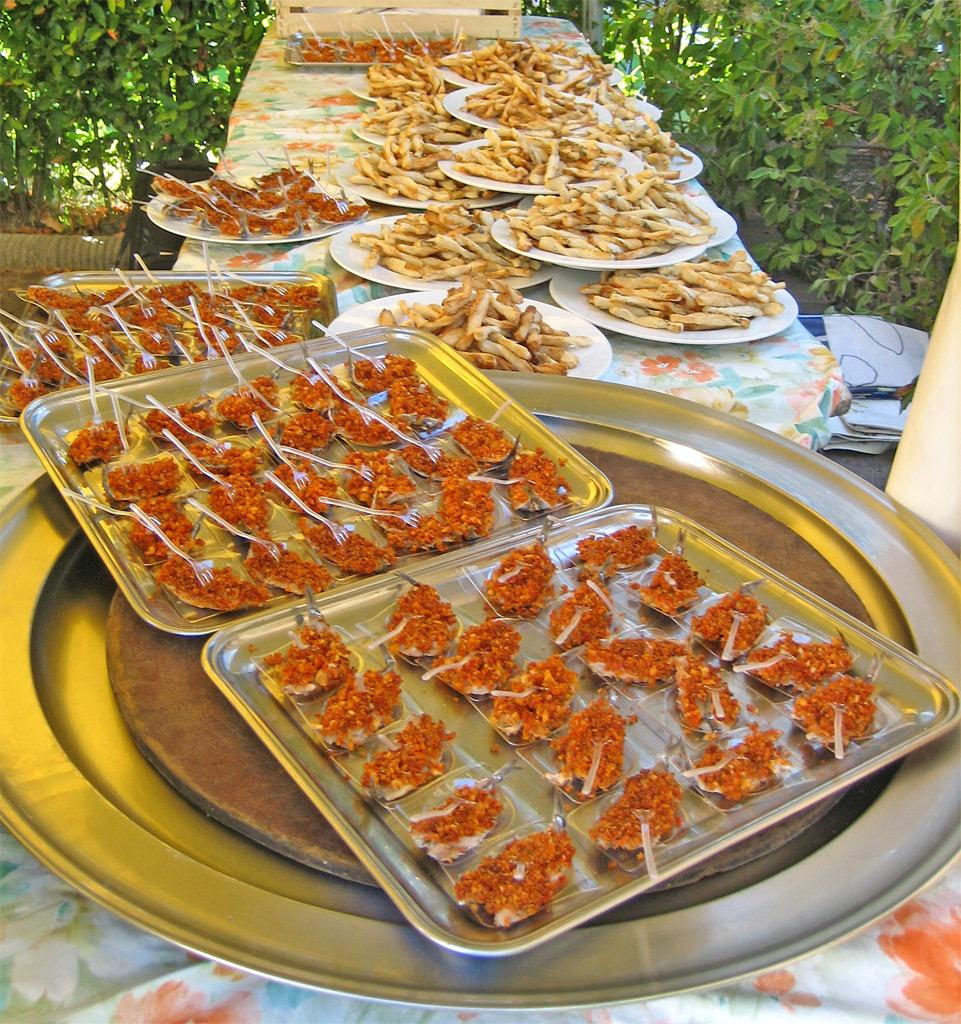What is on the plates that are visible in the image? There are food items on plates in the image. Where are the plates with food items located? The plates are placed on a table. What can be seen in the background of the image? There are plants in the background of the image. How many giraffes can be seen in the image? There are no giraffes present in the image. 